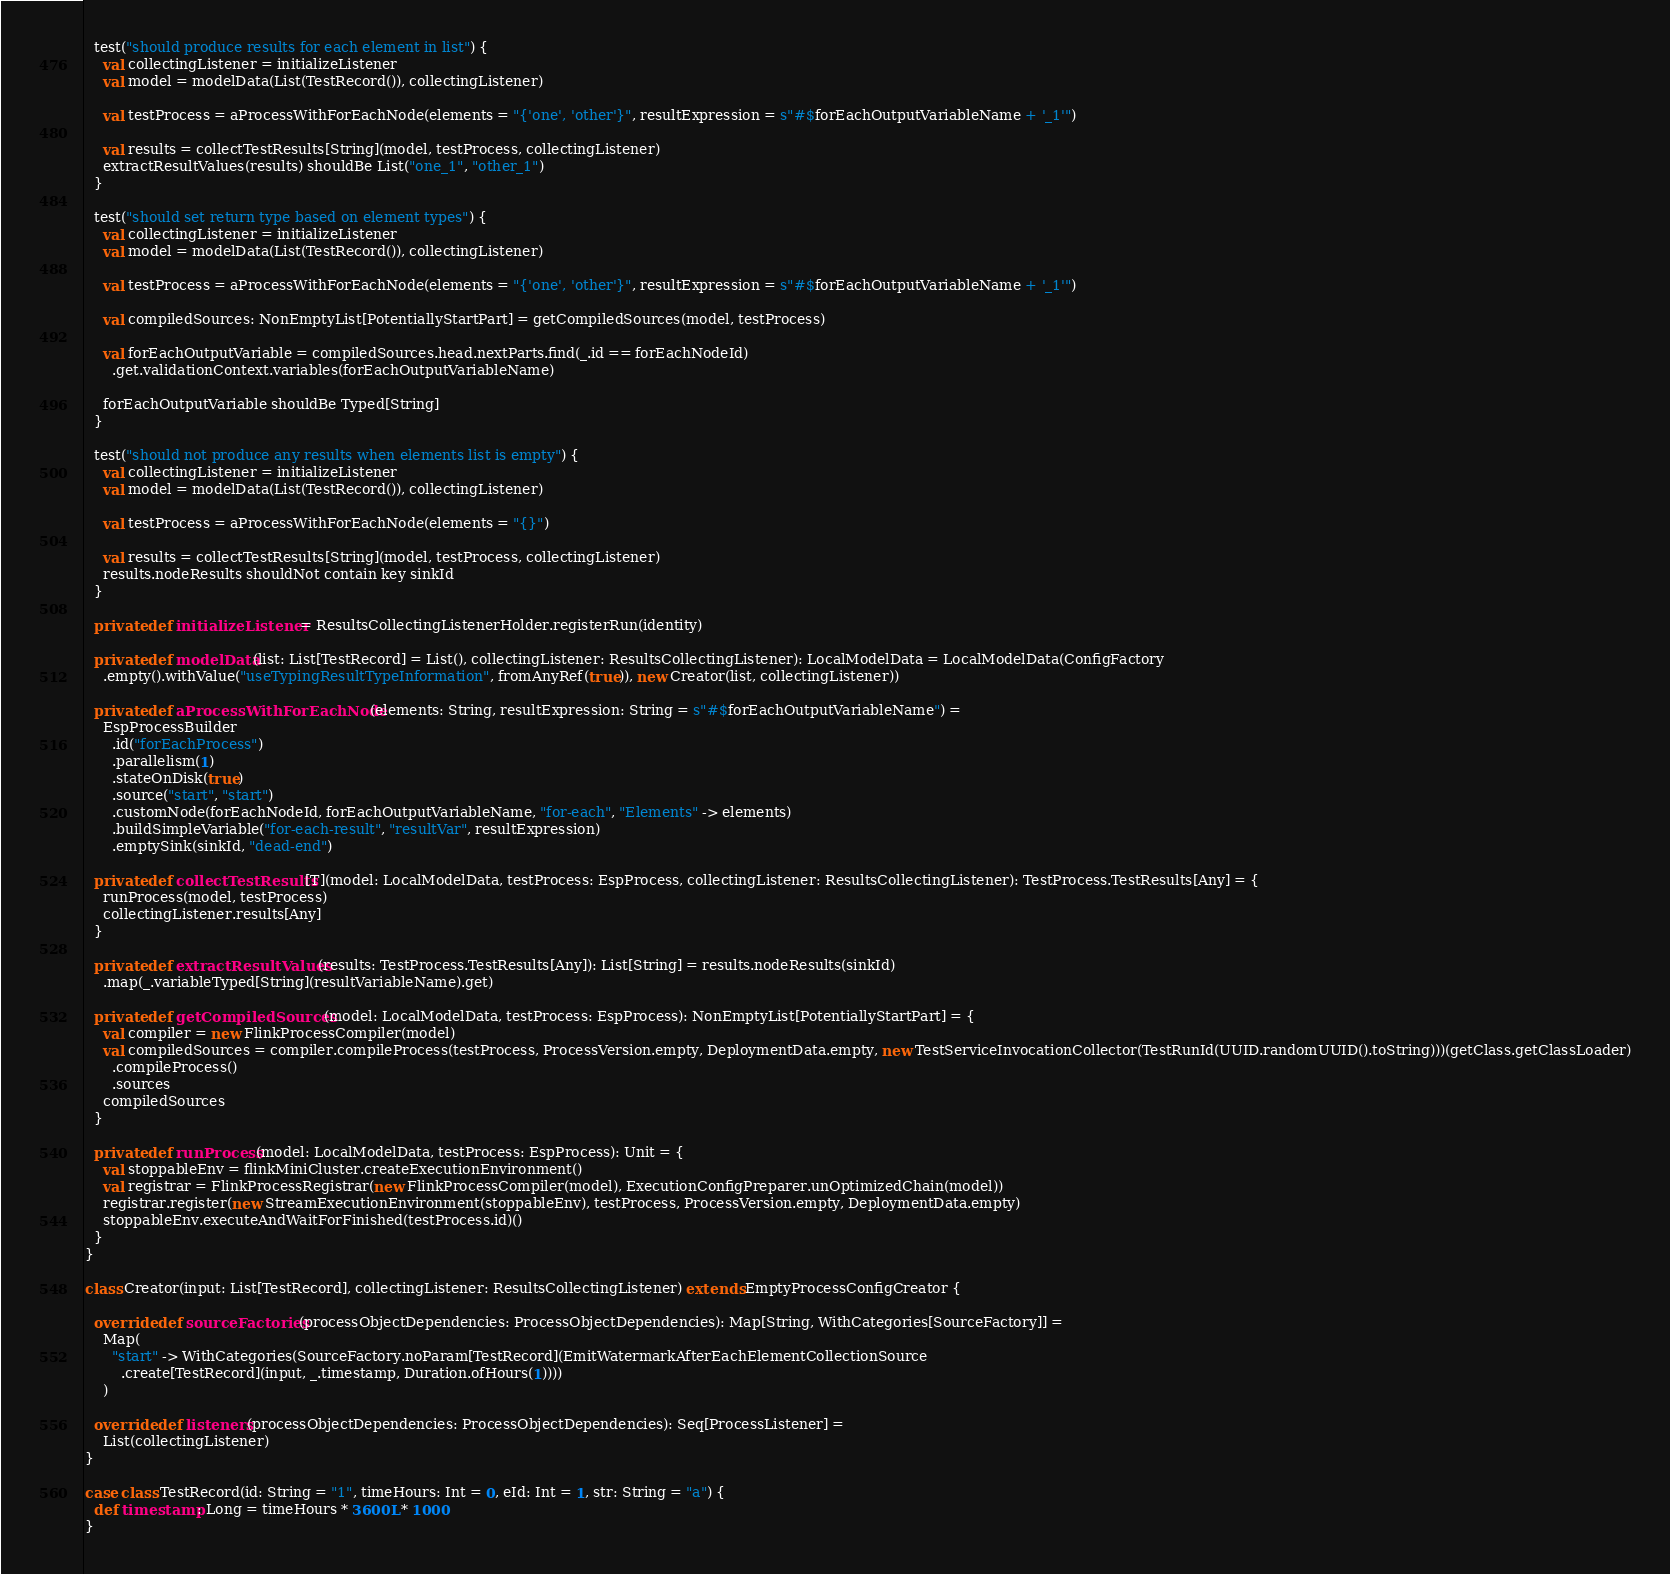<code> <loc_0><loc_0><loc_500><loc_500><_Scala_>
  test("should produce results for each element in list") {
    val collectingListener = initializeListener
    val model = modelData(List(TestRecord()), collectingListener)

    val testProcess = aProcessWithForEachNode(elements = "{'one', 'other'}", resultExpression = s"#$forEachOutputVariableName + '_1'")

    val results = collectTestResults[String](model, testProcess, collectingListener)
    extractResultValues(results) shouldBe List("one_1", "other_1")
  }

  test("should set return type based on element types") {
    val collectingListener = initializeListener
    val model = modelData(List(TestRecord()), collectingListener)

    val testProcess = aProcessWithForEachNode(elements = "{'one', 'other'}", resultExpression = s"#$forEachOutputVariableName + '_1'")

    val compiledSources: NonEmptyList[PotentiallyStartPart] = getCompiledSources(model, testProcess)

    val forEachOutputVariable = compiledSources.head.nextParts.find(_.id == forEachNodeId)
      .get.validationContext.variables(forEachOutputVariableName)

    forEachOutputVariable shouldBe Typed[String]
  }

  test("should not produce any results when elements list is empty") {
    val collectingListener = initializeListener
    val model = modelData(List(TestRecord()), collectingListener)

    val testProcess = aProcessWithForEachNode(elements = "{}")

    val results = collectTestResults[String](model, testProcess, collectingListener)
    results.nodeResults shouldNot contain key sinkId
  }

  private def initializeListener = ResultsCollectingListenerHolder.registerRun(identity)

  private def modelData(list: List[TestRecord] = List(), collectingListener: ResultsCollectingListener): LocalModelData = LocalModelData(ConfigFactory
    .empty().withValue("useTypingResultTypeInformation", fromAnyRef(true)), new Creator(list, collectingListener))

  private def aProcessWithForEachNode(elements: String, resultExpression: String = s"#$forEachOutputVariableName") =
    EspProcessBuilder
      .id("forEachProcess")
      .parallelism(1)
      .stateOnDisk(true)
      .source("start", "start")
      .customNode(forEachNodeId, forEachOutputVariableName, "for-each", "Elements" -> elements)
      .buildSimpleVariable("for-each-result", "resultVar", resultExpression)
      .emptySink(sinkId, "dead-end")

  private def collectTestResults[T](model: LocalModelData, testProcess: EspProcess, collectingListener: ResultsCollectingListener): TestProcess.TestResults[Any] = {
    runProcess(model, testProcess)
    collectingListener.results[Any]
  }

  private def extractResultValues(results: TestProcess.TestResults[Any]): List[String] = results.nodeResults(sinkId)
    .map(_.variableTyped[String](resultVariableName).get)

  private def getCompiledSources(model: LocalModelData, testProcess: EspProcess): NonEmptyList[PotentiallyStartPart] = {
    val compiler = new FlinkProcessCompiler(model)
    val compiledSources = compiler.compileProcess(testProcess, ProcessVersion.empty, DeploymentData.empty, new TestServiceInvocationCollector(TestRunId(UUID.randomUUID().toString)))(getClass.getClassLoader)
      .compileProcess()
      .sources
    compiledSources
  }

  private def runProcess(model: LocalModelData, testProcess: EspProcess): Unit = {
    val stoppableEnv = flinkMiniCluster.createExecutionEnvironment()
    val registrar = FlinkProcessRegistrar(new FlinkProcessCompiler(model), ExecutionConfigPreparer.unOptimizedChain(model))
    registrar.register(new StreamExecutionEnvironment(stoppableEnv), testProcess, ProcessVersion.empty, DeploymentData.empty)
    stoppableEnv.executeAndWaitForFinished(testProcess.id)()
  }
}

class Creator(input: List[TestRecord], collectingListener: ResultsCollectingListener) extends EmptyProcessConfigCreator {

  override def sourceFactories(processObjectDependencies: ProcessObjectDependencies): Map[String, WithCategories[SourceFactory]] =
    Map(
      "start" -> WithCategories(SourceFactory.noParam[TestRecord](EmitWatermarkAfterEachElementCollectionSource
        .create[TestRecord](input, _.timestamp, Duration.ofHours(1))))
    )

  override def listeners(processObjectDependencies: ProcessObjectDependencies): Seq[ProcessListener] =
    List(collectingListener)
}

case class TestRecord(id: String = "1", timeHours: Int = 0, eId: Int = 1, str: String = "a") {
  def timestamp: Long = timeHours * 3600L * 1000
}
</code> 